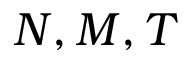Convert formula to latex. <formula><loc_0><loc_0><loc_500><loc_500>N , M , T</formula> 